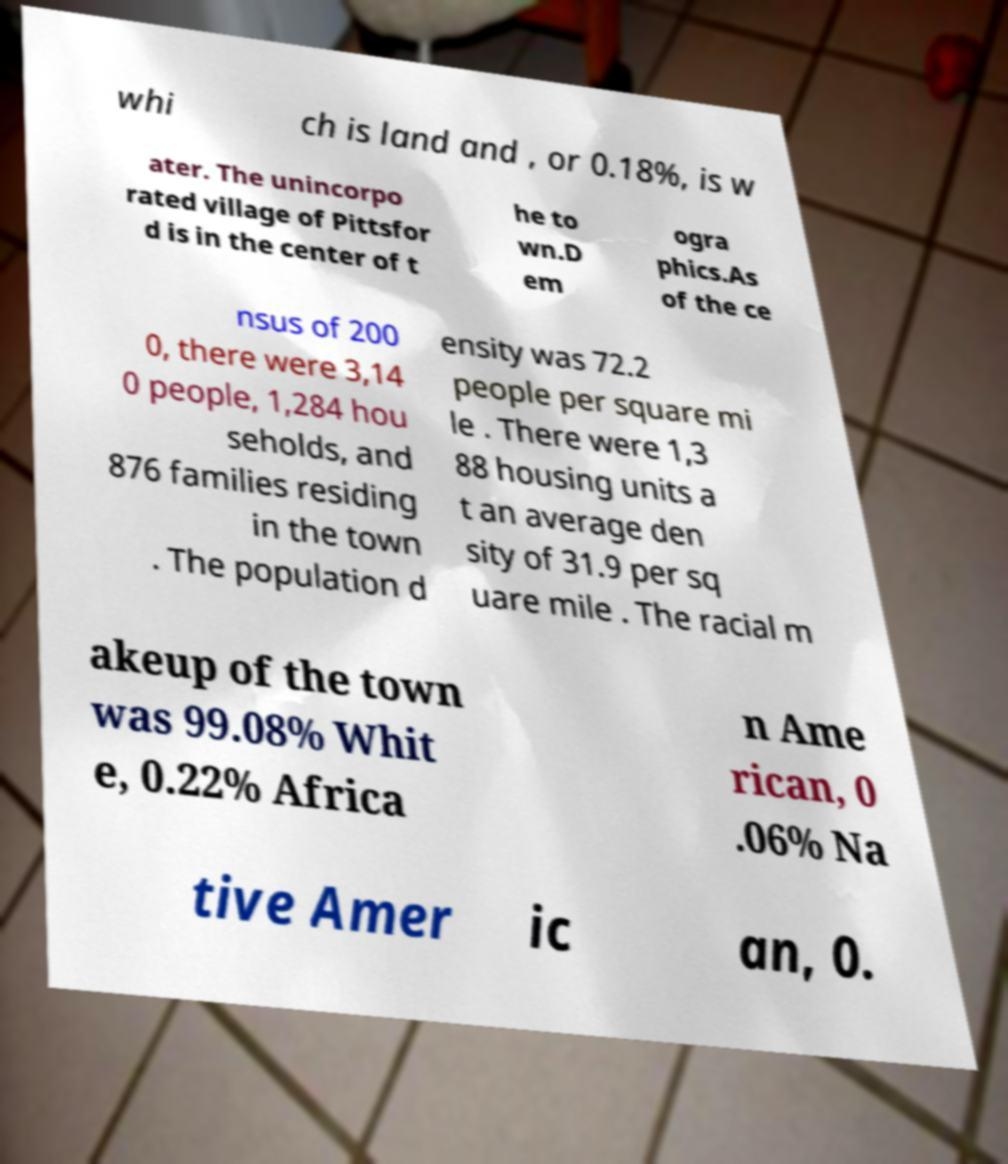Can you accurately transcribe the text from the provided image for me? whi ch is land and , or 0.18%, is w ater. The unincorpo rated village of Pittsfor d is in the center of t he to wn.D em ogra phics.As of the ce nsus of 200 0, there were 3,14 0 people, 1,284 hou seholds, and 876 families residing in the town . The population d ensity was 72.2 people per square mi le . There were 1,3 88 housing units a t an average den sity of 31.9 per sq uare mile . The racial m akeup of the town was 99.08% Whit e, 0.22% Africa n Ame rican, 0 .06% Na tive Amer ic an, 0. 